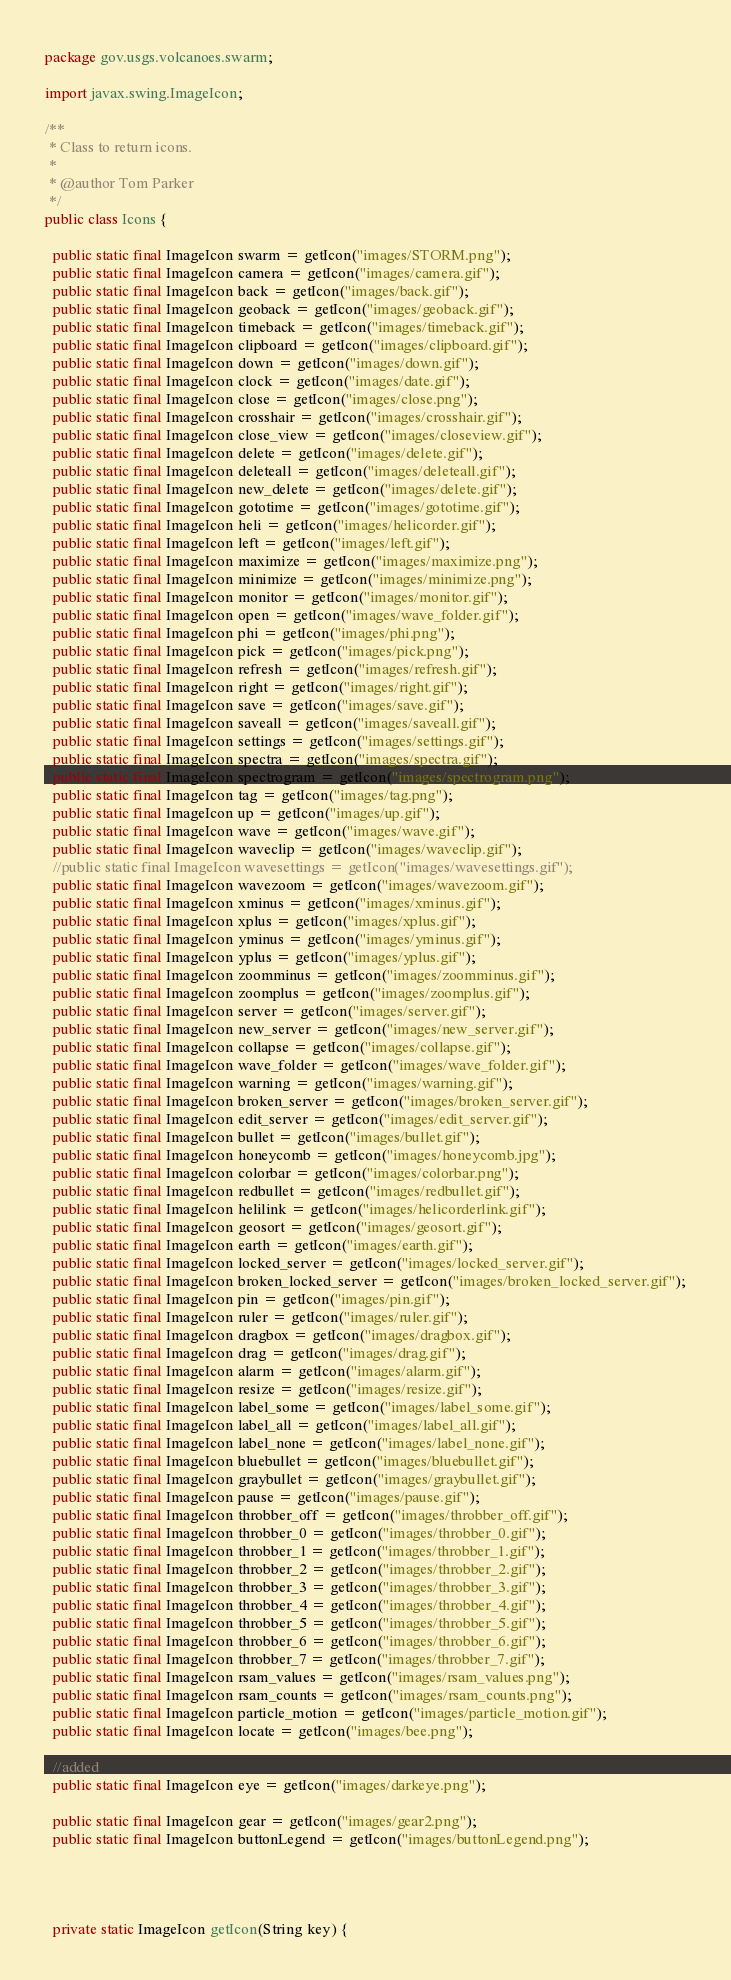<code> <loc_0><loc_0><loc_500><loc_500><_Java_>package gov.usgs.volcanoes.swarm;

import javax.swing.ImageIcon;

/**
 * Class to return icons.
 * 
 * @author Tom Parker
 */
public class Icons {
  
  public static final ImageIcon swarm = getIcon("images/STORM.png");
  public static final ImageIcon camera = getIcon("images/camera.gif");
  public static final ImageIcon back = getIcon("images/back.gif");
  public static final ImageIcon geoback = getIcon("images/geoback.gif");
  public static final ImageIcon timeback = getIcon("images/timeback.gif");
  public static final ImageIcon clipboard = getIcon("images/clipboard.gif");
  public static final ImageIcon down = getIcon("images/down.gif");
  public static final ImageIcon clock = getIcon("images/date.gif");
  public static final ImageIcon close = getIcon("images/close.png");
  public static final ImageIcon crosshair = getIcon("images/crosshair.gif");
  public static final ImageIcon close_view = getIcon("images/closeview.gif");
  public static final ImageIcon delete = getIcon("images/delete.gif");
  public static final ImageIcon deleteall = getIcon("images/deleteall.gif");
  public static final ImageIcon new_delete = getIcon("images/delete.gif");
  public static final ImageIcon gototime = getIcon("images/gototime.gif");
  public static final ImageIcon heli = getIcon("images/helicorder.gif");
  public static final ImageIcon left = getIcon("images/left.gif");
  public static final ImageIcon maximize = getIcon("images/maximize.png");
  public static final ImageIcon minimize = getIcon("images/minimize.png");
  public static final ImageIcon monitor = getIcon("images/monitor.gif");
  public static final ImageIcon open = getIcon("images/wave_folder.gif");
  public static final ImageIcon phi = getIcon("images/phi.png");
  public static final ImageIcon pick = getIcon("images/pick.png");
  public static final ImageIcon refresh = getIcon("images/refresh.gif");
  public static final ImageIcon right = getIcon("images/right.gif");
  public static final ImageIcon save = getIcon("images/save.gif");
  public static final ImageIcon saveall = getIcon("images/saveall.gif");
  public static final ImageIcon settings = getIcon("images/settings.gif");
  public static final ImageIcon spectra = getIcon("images/spectra.gif");
  public static final ImageIcon spectrogram = getIcon("images/spectrogram.png");
  public static final ImageIcon tag = getIcon("images/tag.png");
  public static final ImageIcon up = getIcon("images/up.gif");
  public static final ImageIcon wave = getIcon("images/wave.gif");
  public static final ImageIcon waveclip = getIcon("images/waveclip.gif");
  //public static final ImageIcon wavesettings = getIcon("images/wavesettings.gif");
  public static final ImageIcon wavezoom = getIcon("images/wavezoom.gif");
  public static final ImageIcon xminus = getIcon("images/xminus.gif");
  public static final ImageIcon xplus = getIcon("images/xplus.gif");
  public static final ImageIcon yminus = getIcon("images/yminus.gif");
  public static final ImageIcon yplus = getIcon("images/yplus.gif");
  public static final ImageIcon zoomminus = getIcon("images/zoomminus.gif");
  public static final ImageIcon zoomplus = getIcon("images/zoomplus.gif");
  public static final ImageIcon server = getIcon("images/server.gif");
  public static final ImageIcon new_server = getIcon("images/new_server.gif");
  public static final ImageIcon collapse = getIcon("images/collapse.gif");
  public static final ImageIcon wave_folder = getIcon("images/wave_folder.gif");
  public static final ImageIcon warning = getIcon("images/warning.gif");
  public static final ImageIcon broken_server = getIcon("images/broken_server.gif");
  public static final ImageIcon edit_server = getIcon("images/edit_server.gif");
  public static final ImageIcon bullet = getIcon("images/bullet.gif");
  public static final ImageIcon honeycomb = getIcon("images/honeycomb.jpg");
  public static final ImageIcon colorbar = getIcon("images/colorbar.png");
  public static final ImageIcon redbullet = getIcon("images/redbullet.gif");
  public static final ImageIcon helilink = getIcon("images/helicorderlink.gif");
  public static final ImageIcon geosort = getIcon("images/geosort.gif");
  public static final ImageIcon earth = getIcon("images/earth.gif");
  public static final ImageIcon locked_server = getIcon("images/locked_server.gif");
  public static final ImageIcon broken_locked_server = getIcon("images/broken_locked_server.gif");
  public static final ImageIcon pin = getIcon("images/pin.gif");
  public static final ImageIcon ruler = getIcon("images/ruler.gif");
  public static final ImageIcon dragbox = getIcon("images/dragbox.gif");
  public static final ImageIcon drag = getIcon("images/drag.gif");
  public static final ImageIcon alarm = getIcon("images/alarm.gif");
  public static final ImageIcon resize = getIcon("images/resize.gif");
  public static final ImageIcon label_some = getIcon("images/label_some.gif");
  public static final ImageIcon label_all = getIcon("images/label_all.gif");
  public static final ImageIcon label_none = getIcon("images/label_none.gif");
  public static final ImageIcon bluebullet = getIcon("images/bluebullet.gif");
  public static final ImageIcon graybullet = getIcon("images/graybullet.gif");
  public static final ImageIcon pause = getIcon("images/pause.gif");
  public static final ImageIcon throbber_off = getIcon("images/throbber_off.gif");
  public static final ImageIcon throbber_0 = getIcon("images/throbber_0.gif");
  public static final ImageIcon throbber_1 = getIcon("images/throbber_1.gif");
  public static final ImageIcon throbber_2 = getIcon("images/throbber_2.gif");
  public static final ImageIcon throbber_3 = getIcon("images/throbber_3.gif");
  public static final ImageIcon throbber_4 = getIcon("images/throbber_4.gif");
  public static final ImageIcon throbber_5 = getIcon("images/throbber_5.gif");
  public static final ImageIcon throbber_6 = getIcon("images/throbber_6.gif");
  public static final ImageIcon throbber_7 = getIcon("images/throbber_7.gif");
  public static final ImageIcon rsam_values = getIcon("images/rsam_values.png");
  public static final ImageIcon rsam_counts = getIcon("images/rsam_counts.png");
  public static final ImageIcon particle_motion = getIcon("images/particle_motion.gif");
  public static final ImageIcon locate = getIcon("images/bee.png");
  
  //added
  public static final ImageIcon eye = getIcon("images/darkeye.png");
  
  public static final ImageIcon gear = getIcon("images/gear2.png");
  public static final ImageIcon buttonLegend = getIcon("images/buttonLegend.png");
  

  
   
  private static ImageIcon getIcon(String key) {</code> 